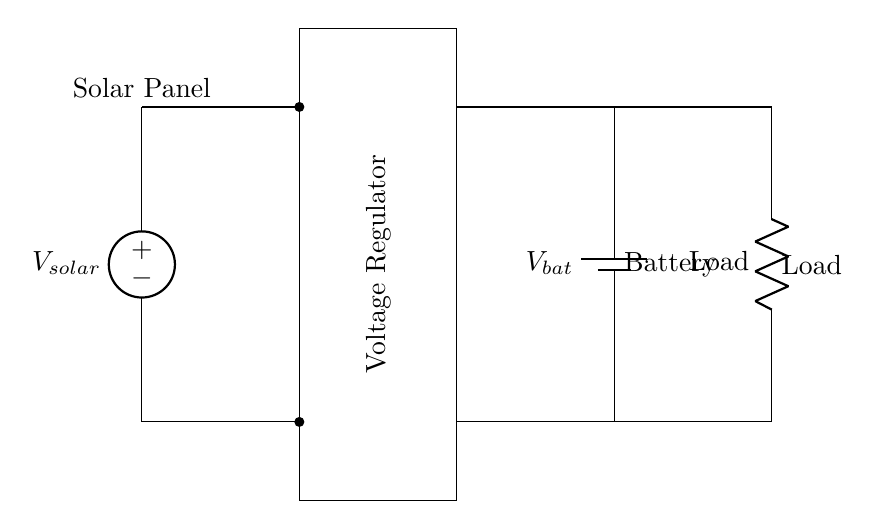What is the output of the solar panel? The output of the solar panel corresponds to the voltage source labeled as V_solar in the circuit.
Answer: V_solar What component regulates the voltage? The component that regulates the voltage is identified by the rectangle labeled as Voltage Regulator.
Answer: Voltage Regulator What is the type of battery used in this circuit? The battery is indicated by the symbol labeled as V_bat in the diagram, which signifies a rechargeable battery type.
Answer: V_bat What is the load in this circuit? The load is represented by the resistor symbol labeled as Load, which indicates a component consuming power from the battery.
Answer: Load How many main components are used in this charging system? The circuit includes three main components: the solar panel, the voltage regulator, and the battery, along with the load.
Answer: Three What can be inferred about the role of the voltage regulator? The voltage regulator's role is to ensure that the output voltage remains constant and appropriate for charging the battery regardless of variations in solar input.
Answer: Maintain constant voltage What is the direction of current flow in this circuit? The current flows from the solar panel to the voltage regulator, then to the battery, and finally to the load, following the standard circuit flow.
Answer: Solar panel to load 